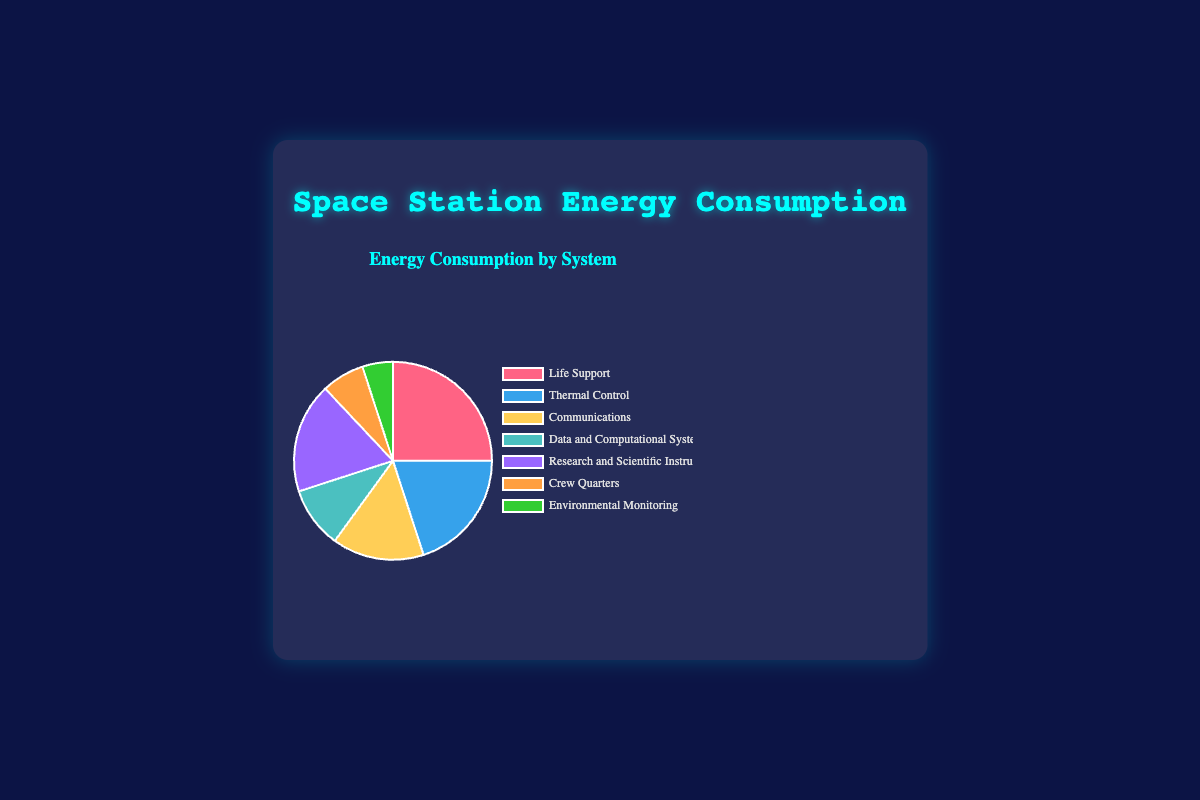What system uses the highest percentage of energy consumption? The pie chart indicates that the Life Support system consumes the highest percentage of energy, at 25%.
Answer: Life Support Which system uses less energy: Crew Quarters or Environmental Monitoring? The pie chart shows that Crew Quarters uses 7% of the energy, while Environmental Monitoring uses 5%. Therefore, Environmental Monitoring uses less energy.
Answer: Environmental Monitoring What is the combined energy consumption percentage of Life Support and Thermal Control systems? By adding the percentages of Life Support (25%) and Thermal Control (20%), the total combined consumption is 25% + 20% = 45%.
Answer: 45% Which system consumes more energy: Research and Scientific Instruments or Communications? The pie chart displays that Research and Scientific Instruments consumes 18% of the energy, while Communications consumes 15%. Thus, Research and Scientific Instruments consume more energy.
Answer: Research and Scientific Instruments What is the total energy consumption percentage of systems that consume less than 10% each? Summing the percentages of Data and Computational Systems (10%), Crew Quarters (7%), and Environmental Monitoring (5%): 10% + 7% + 5% = 22%.
Answer: 22% What is the average energy consumption percentage across all systems? To find the average: Sum of all percentages (25% + 20% + 15% + 10% + 18% + 7% + 5%) / Number of systems (7) = 100% / 7 ≈ 14.29%.
Answer: 14.29% What is the difference in energy consumption between the system that consumes the most and the one that consumes the least? The Life Support system consumes the most energy at 25%, and Environmental Monitoring consumes the least at 5%. The difference is 25% - 5% = 20%.
Answer: 20% Which systems use an energy consumption percentage of exactly 10%? The Data and Computational Systems consumes exactly 10% of the energy.
Answer: Data and Computational Systems What percentage of energy consumption is used by non-communication systems? Subtract the percentage of Communications (15%) from the total (100%): 100% - 15% = 85%.
Answer: 85% 